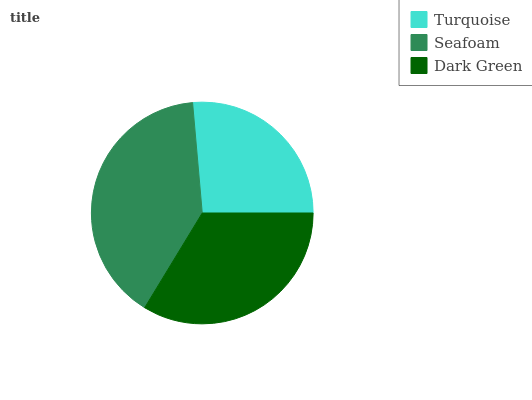Is Turquoise the minimum?
Answer yes or no. Yes. Is Seafoam the maximum?
Answer yes or no. Yes. Is Dark Green the minimum?
Answer yes or no. No. Is Dark Green the maximum?
Answer yes or no. No. Is Seafoam greater than Dark Green?
Answer yes or no. Yes. Is Dark Green less than Seafoam?
Answer yes or no. Yes. Is Dark Green greater than Seafoam?
Answer yes or no. No. Is Seafoam less than Dark Green?
Answer yes or no. No. Is Dark Green the high median?
Answer yes or no. Yes. Is Dark Green the low median?
Answer yes or no. Yes. Is Seafoam the high median?
Answer yes or no. No. Is Turquoise the low median?
Answer yes or no. No. 